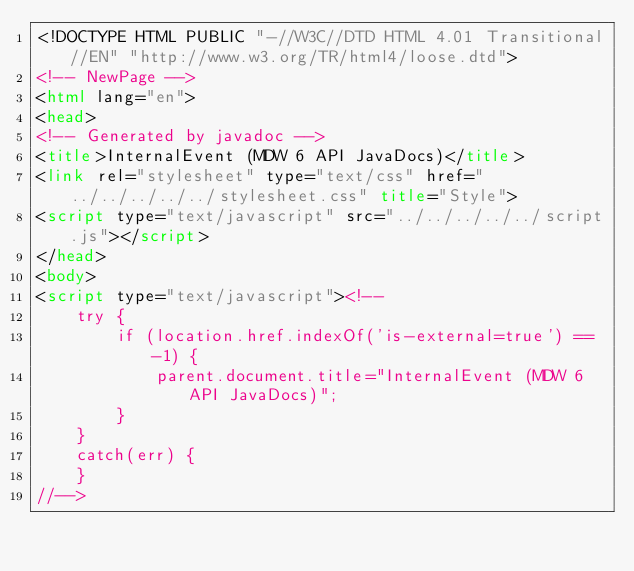Convert code to text. <code><loc_0><loc_0><loc_500><loc_500><_HTML_><!DOCTYPE HTML PUBLIC "-//W3C//DTD HTML 4.01 Transitional//EN" "http://www.w3.org/TR/html4/loose.dtd">
<!-- NewPage -->
<html lang="en">
<head>
<!-- Generated by javadoc -->
<title>InternalEvent (MDW 6 API JavaDocs)</title>
<link rel="stylesheet" type="text/css" href="../../../../../stylesheet.css" title="Style">
<script type="text/javascript" src="../../../../../script.js"></script>
</head>
<body>
<script type="text/javascript"><!--
    try {
        if (location.href.indexOf('is-external=true') == -1) {
            parent.document.title="InternalEvent (MDW 6 API JavaDocs)";
        }
    }
    catch(err) {
    }
//--></code> 